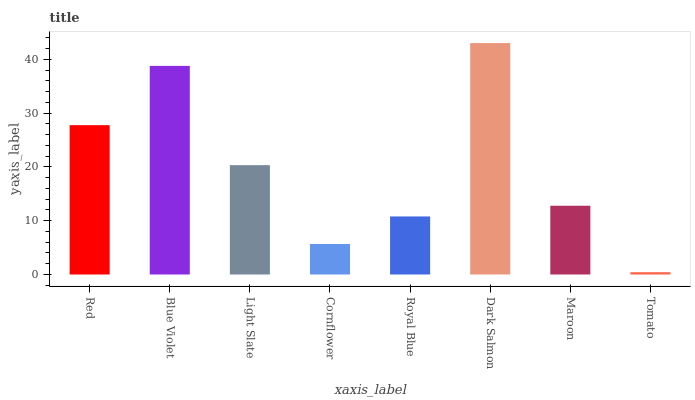Is Tomato the minimum?
Answer yes or no. Yes. Is Dark Salmon the maximum?
Answer yes or no. Yes. Is Blue Violet the minimum?
Answer yes or no. No. Is Blue Violet the maximum?
Answer yes or no. No. Is Blue Violet greater than Red?
Answer yes or no. Yes. Is Red less than Blue Violet?
Answer yes or no. Yes. Is Red greater than Blue Violet?
Answer yes or no. No. Is Blue Violet less than Red?
Answer yes or no. No. Is Light Slate the high median?
Answer yes or no. Yes. Is Maroon the low median?
Answer yes or no. Yes. Is Tomato the high median?
Answer yes or no. No. Is Royal Blue the low median?
Answer yes or no. No. 